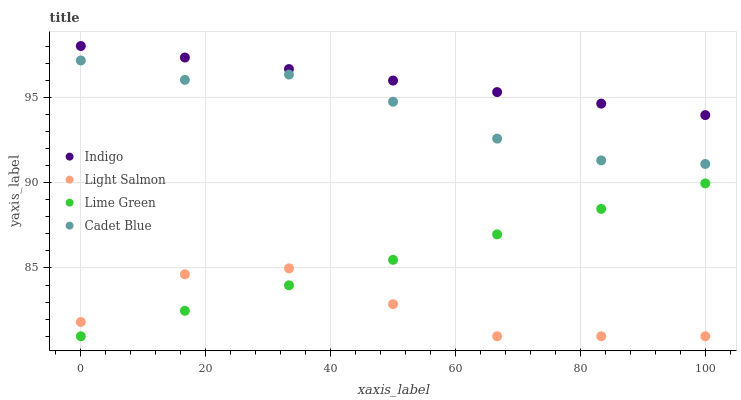Does Light Salmon have the minimum area under the curve?
Answer yes or no. Yes. Does Indigo have the maximum area under the curve?
Answer yes or no. Yes. Does Cadet Blue have the minimum area under the curve?
Answer yes or no. No. Does Cadet Blue have the maximum area under the curve?
Answer yes or no. No. Is Lime Green the smoothest?
Answer yes or no. Yes. Is Light Salmon the roughest?
Answer yes or no. Yes. Is Cadet Blue the smoothest?
Answer yes or no. No. Is Cadet Blue the roughest?
Answer yes or no. No. Does Lime Green have the lowest value?
Answer yes or no. Yes. Does Cadet Blue have the lowest value?
Answer yes or no. No. Does Indigo have the highest value?
Answer yes or no. Yes. Does Cadet Blue have the highest value?
Answer yes or no. No. Is Cadet Blue less than Indigo?
Answer yes or no. Yes. Is Indigo greater than Cadet Blue?
Answer yes or no. Yes. Does Lime Green intersect Light Salmon?
Answer yes or no. Yes. Is Lime Green less than Light Salmon?
Answer yes or no. No. Is Lime Green greater than Light Salmon?
Answer yes or no. No. Does Cadet Blue intersect Indigo?
Answer yes or no. No. 